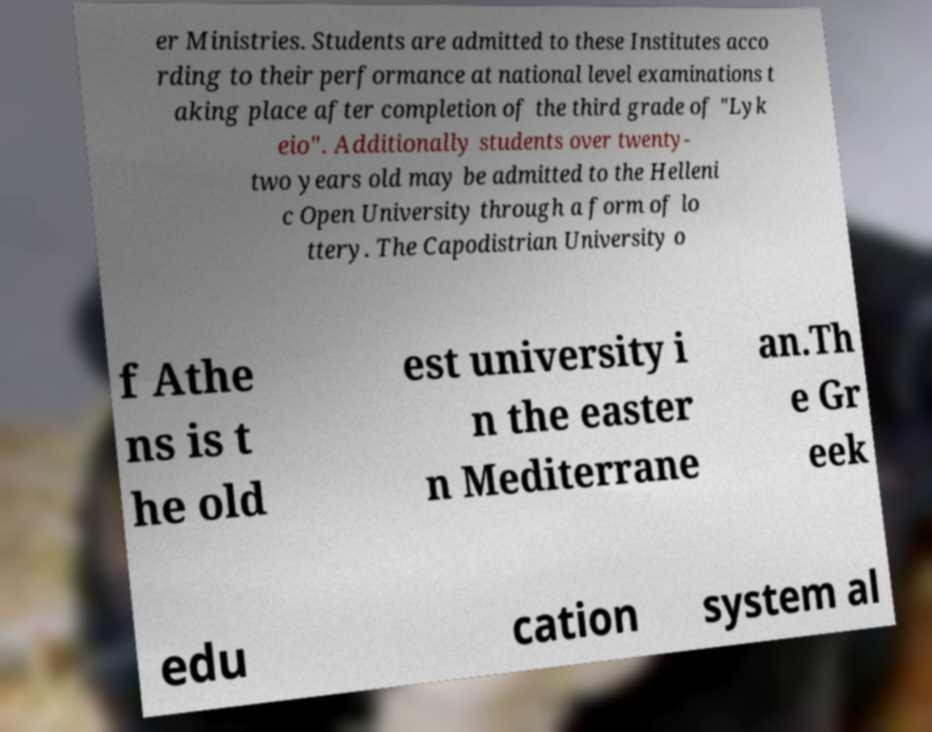For documentation purposes, I need the text within this image transcribed. Could you provide that? er Ministries. Students are admitted to these Institutes acco rding to their performance at national level examinations t aking place after completion of the third grade of "Lyk eio". Additionally students over twenty- two years old may be admitted to the Helleni c Open University through a form of lo ttery. The Capodistrian University o f Athe ns is t he old est university i n the easter n Mediterrane an.Th e Gr eek edu cation system al 